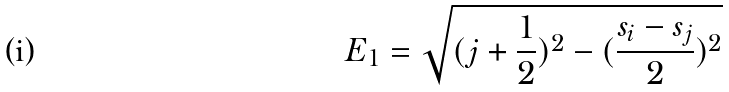Convert formula to latex. <formula><loc_0><loc_0><loc_500><loc_500>E _ { 1 } = \sqrt { ( j + \frac { 1 } { 2 } ) ^ { 2 } - ( \frac { s _ { i } - s _ { j } } { 2 } ) ^ { 2 } }</formula> 